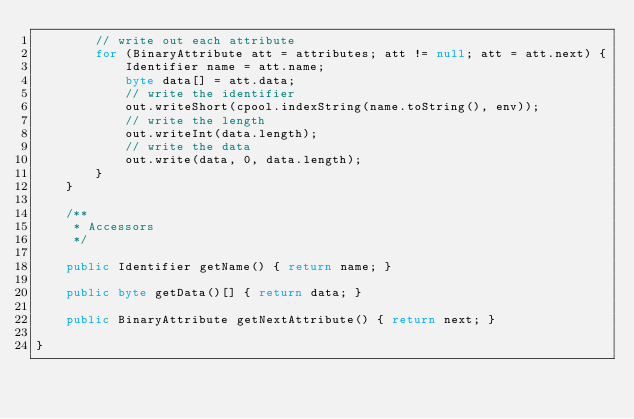Convert code to text. <code><loc_0><loc_0><loc_500><loc_500><_Java_>        // write out each attribute
        for (BinaryAttribute att = attributes; att != null; att = att.next) {
            Identifier name = att.name;
            byte data[] = att.data;
            // write the identifier
            out.writeShort(cpool.indexString(name.toString(), env));
            // write the length
            out.writeInt(data.length);
            // write the data
            out.write(data, 0, data.length);
        }
    }

    /**
     * Accessors
     */

    public Identifier getName() { return name; }

    public byte getData()[] { return data; }

    public BinaryAttribute getNextAttribute() { return next; }

}
</code> 